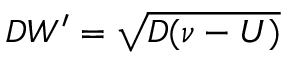Convert formula to latex. <formula><loc_0><loc_0><loc_500><loc_500>D W ^ { \prime } = \sqrt { D ( \nu - U ) }</formula> 